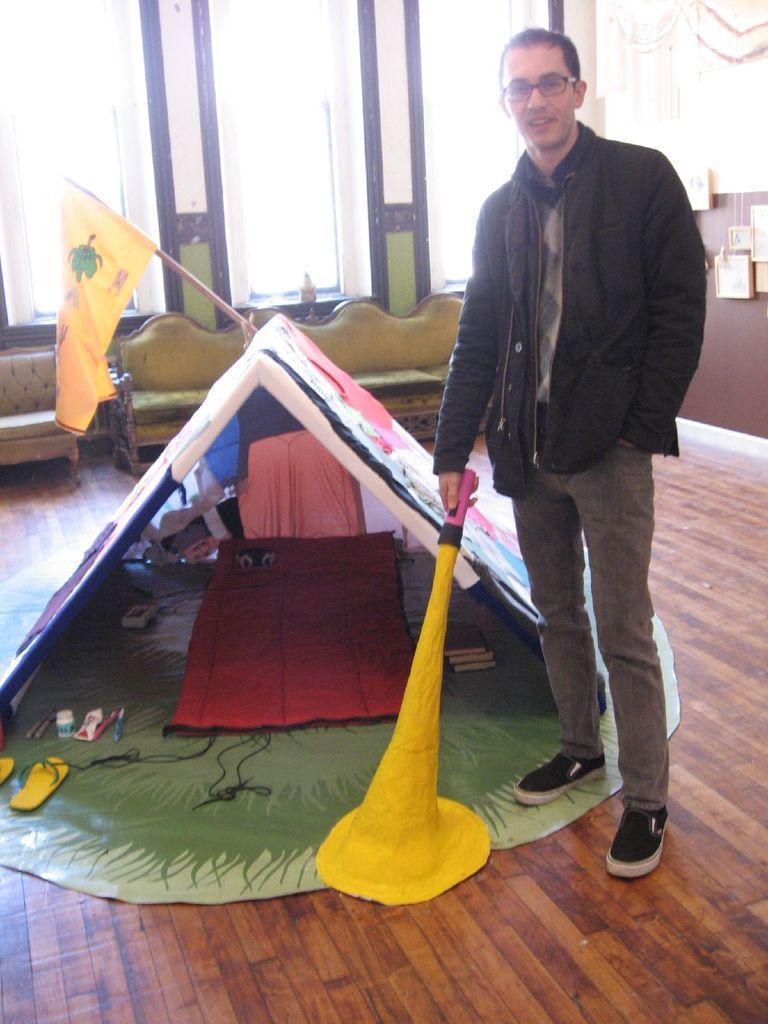Can you describe this image briefly? In this image I can see a person wearing black jacket and spectacles is standing and holding an object which is yellow, black and pink in color. I can see a small tent, few couches, a yellow colored flag and few other objects on the brown colored floor. In the background I can see the wall, few objects hanged to the wall and few windows. 